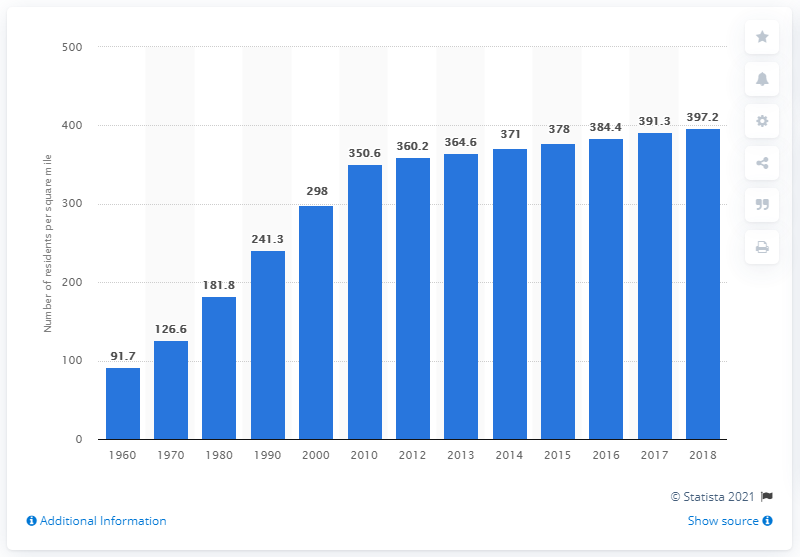Point out several critical features in this image. In 2018, the population density of Florida was 397.2 people per square mile. 